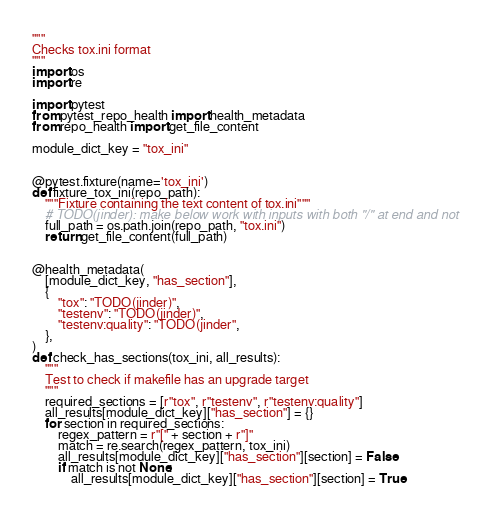<code> <loc_0><loc_0><loc_500><loc_500><_Python_>"""
Checks tox.ini format
"""
import os
import re

import pytest
from pytest_repo_health import health_metadata
from repo_health import get_file_content

module_dict_key = "tox_ini"


@pytest.fixture(name='tox_ini')
def fixture_tox_ini(repo_path):
    """Fixture containing the text content of tox.ini"""
    # TODO(jinder): make below work with inputs with both "/" at end and not
    full_path = os.path.join(repo_path, "tox.ini")
    return get_file_content(full_path)


@health_metadata(
    [module_dict_key, "has_section"],
    {
        "tox": "TODO(jinder)",
        "testenv": "TODO(jinder)",
        "testenv:quality": "TODO(jinder",
    },
)
def check_has_sections(tox_ini, all_results):
    """
    Test to check if makefile has an upgrade target
    """
    required_sections = [r"tox", r"testenv", r"testenv:quality"]
    all_results[module_dict_key]["has_section"] = {}
    for section in required_sections:
        regex_pattern = r"[" + section + r"]"
        match = re.search(regex_pattern, tox_ini)
        all_results[module_dict_key]["has_section"][section] = False
        if match is not None:
            all_results[module_dict_key]["has_section"][section] = True
</code> 